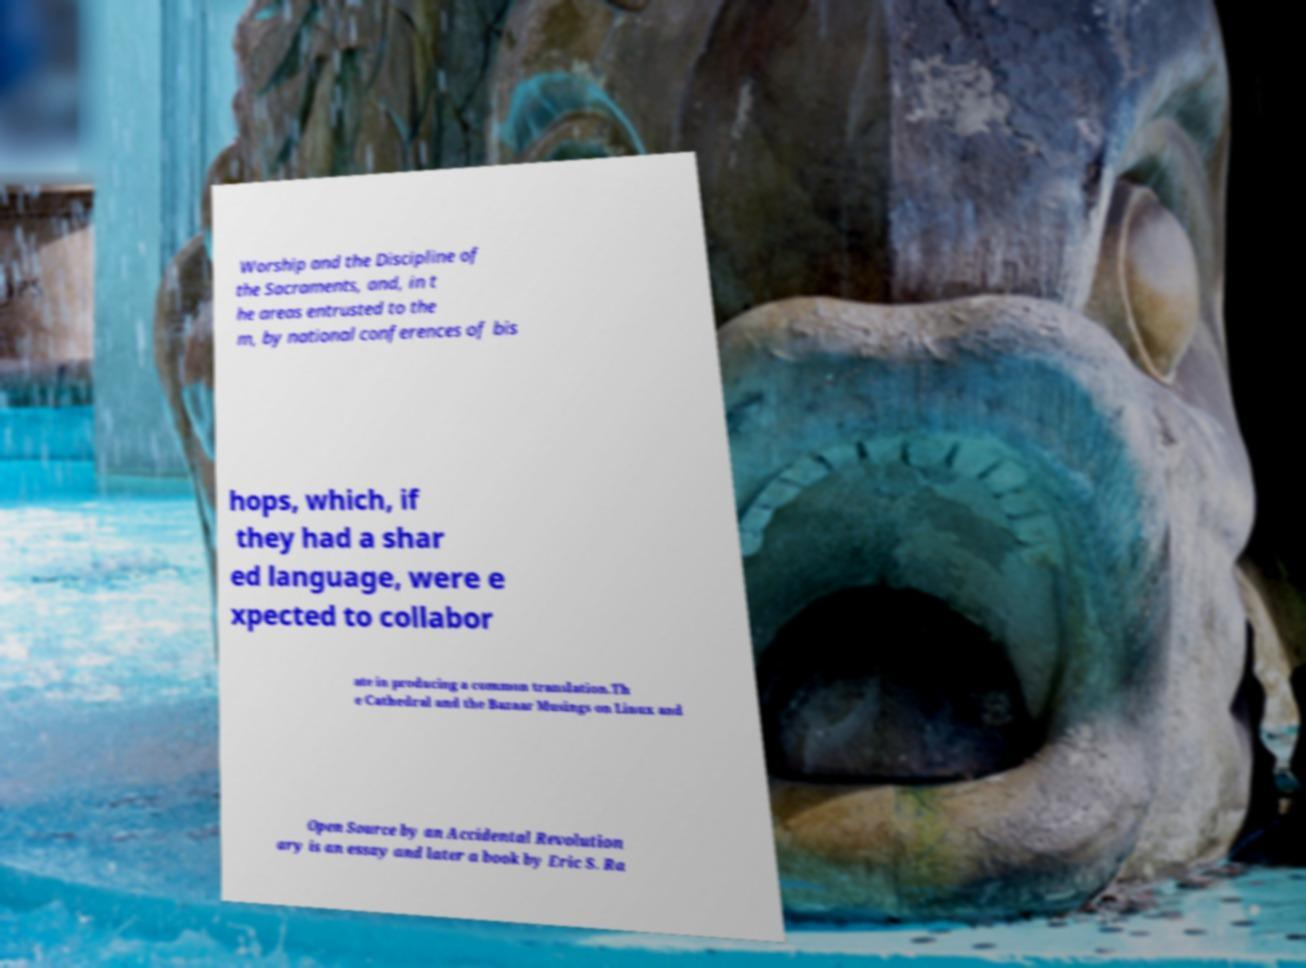Could you assist in decoding the text presented in this image and type it out clearly? Worship and the Discipline of the Sacraments, and, in t he areas entrusted to the m, by national conferences of bis hops, which, if they had a shar ed language, were e xpected to collabor ate in producing a common translation.Th e Cathedral and the Bazaar Musings on Linux and Open Source by an Accidental Revolution ary is an essay and later a book by Eric S. Ra 